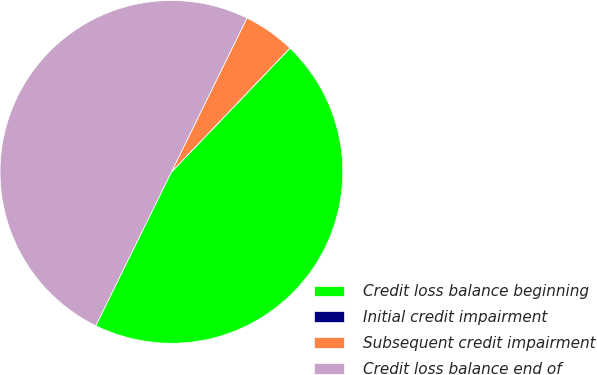Convert chart. <chart><loc_0><loc_0><loc_500><loc_500><pie_chart><fcel>Credit loss balance beginning<fcel>Initial credit impairment<fcel>Subsequent credit impairment<fcel>Credit loss balance end of<nl><fcel>45.12%<fcel>0.01%<fcel>4.88%<fcel>49.99%<nl></chart> 